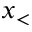Convert formula to latex. <formula><loc_0><loc_0><loc_500><loc_500>x _ { < }</formula> 